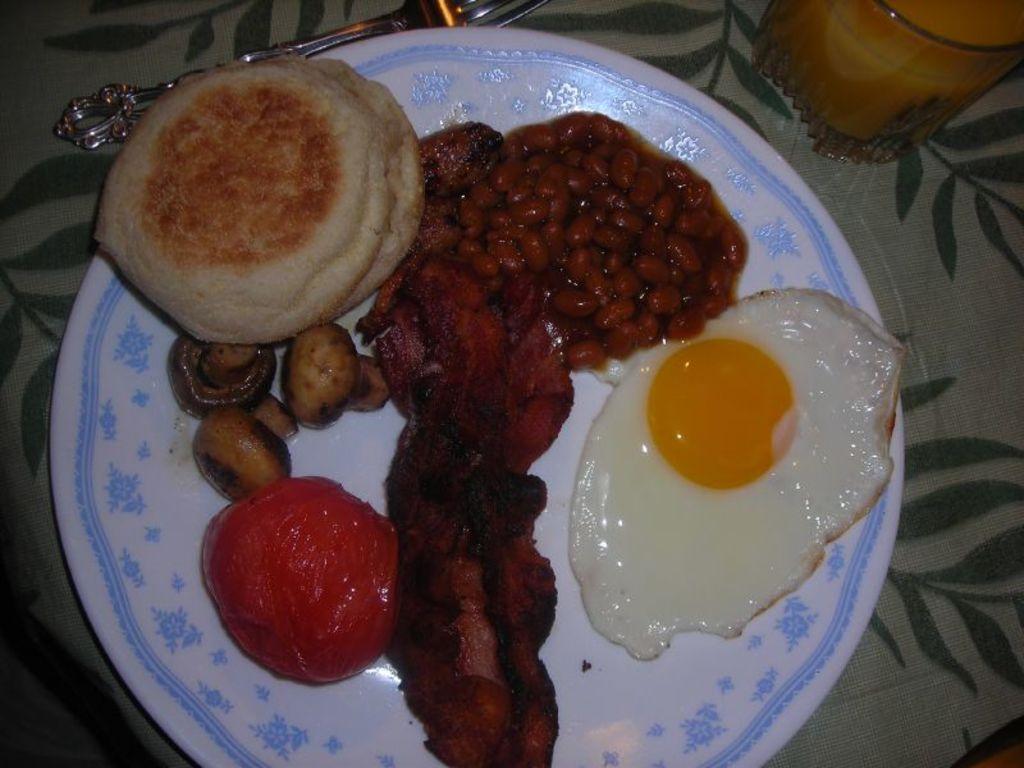In one or two sentences, can you explain what this image depicts? In this picture I can observe some food places in the plate. The plate is in white color. The food is in red, brown and cream colors. On the top right side I can observe a glass with some drink in it. 